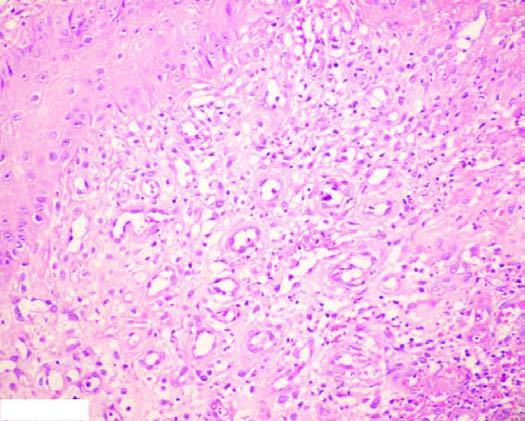does the wedge-shaped infarct have inflammatory cell infiltrate, newly formed blood vessels and young fibrous tissue in loose matrix?
Answer the question using a single word or phrase. No 